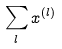<formula> <loc_0><loc_0><loc_500><loc_500>\sum _ { l } x ^ { ( l ) }</formula> 